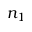<formula> <loc_0><loc_0><loc_500><loc_500>n _ { 1 }</formula> 